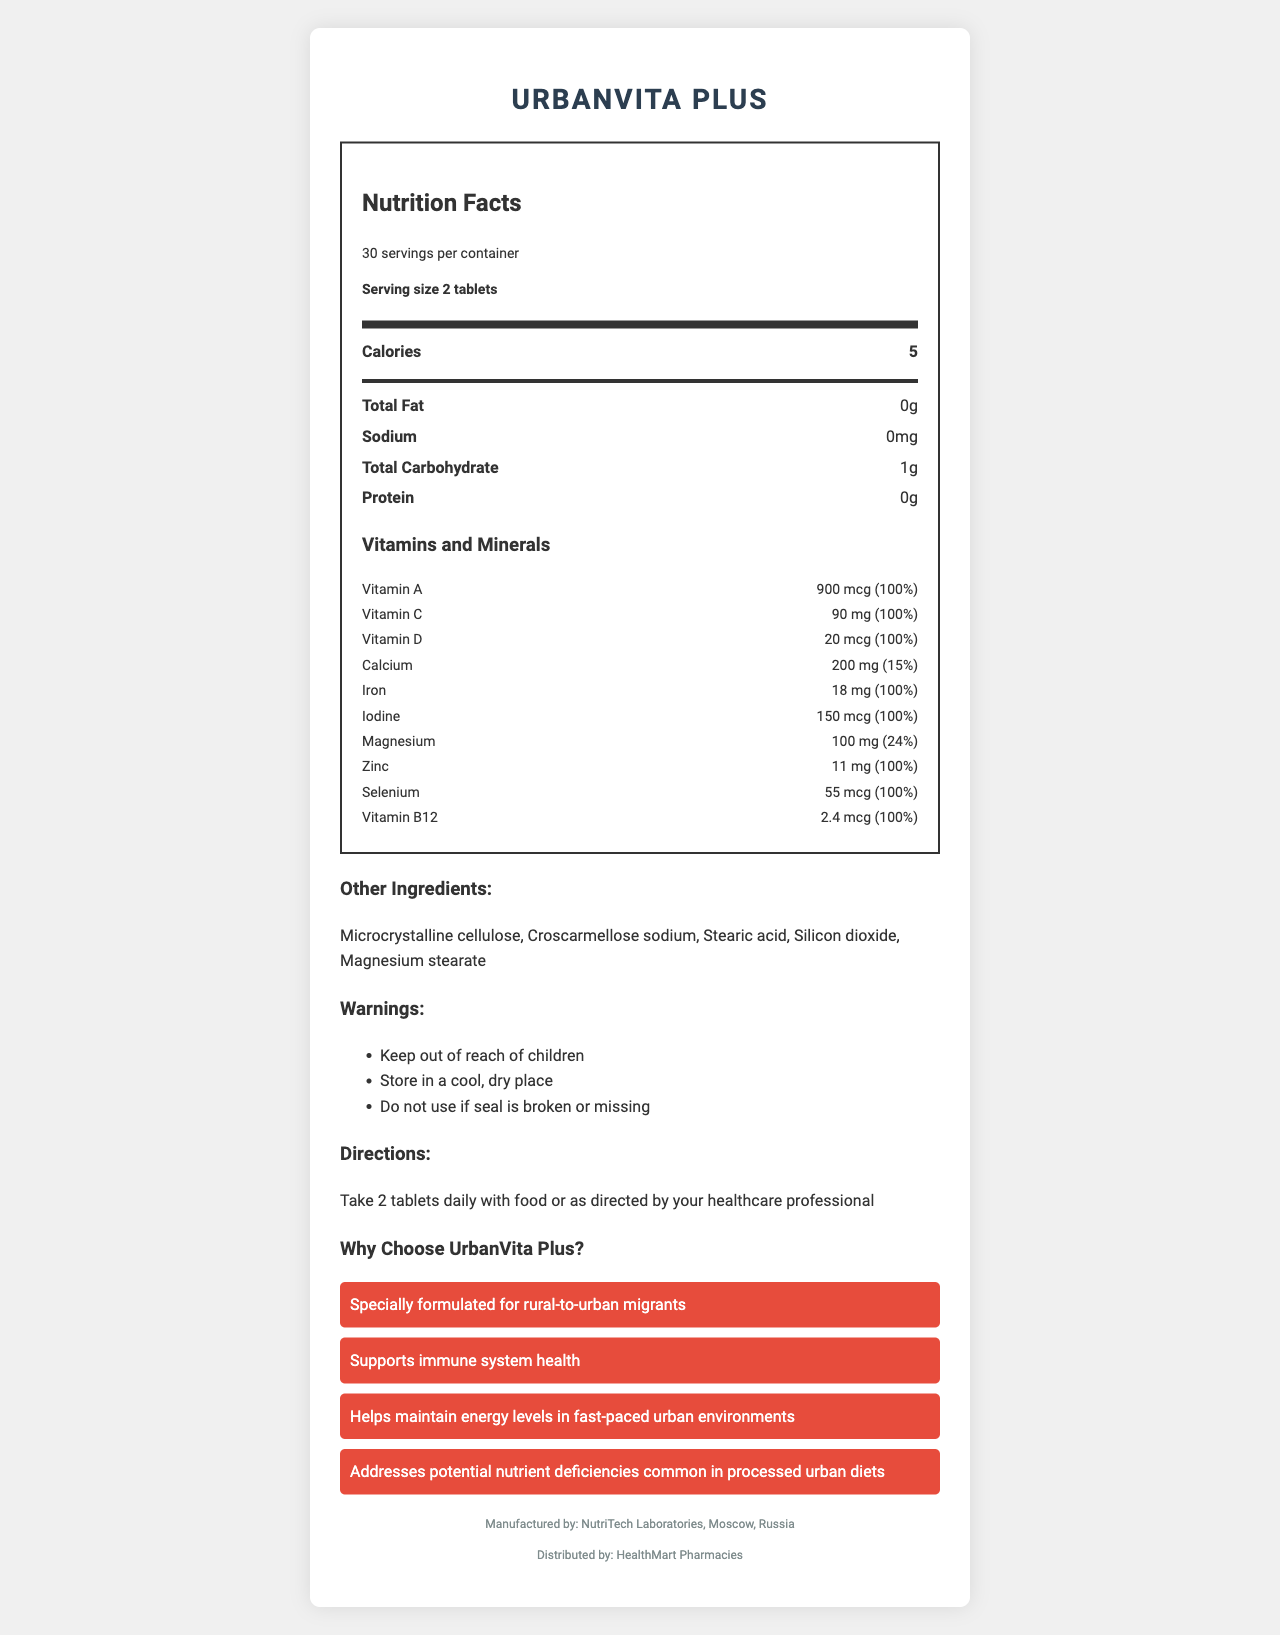which product name is displayed? The document is titled "UrbanVita Plus Nutrition Facts," indicating the product name is UrbanVita Plus.
Answer: UrbanVita Plus what is the serving size? The document states "Serving size: 2 tablets."
Answer: 2 tablets how many servings are there per container? The document indicates there are 30 servings per container.
Answer: 30 how many calories are in a serving? The document lists that each serving contains 5 calories.
Answer: 5 how much Vitamin C is in a serving? Under the vitamins and minerals section, Vitamin C is listed as containing 90 mg per serving with a daily value of 100%.
Answer: 90 mg which vitamin has the highest percentage daily value? A. Vitamin A B. Vitamin D C. Calcium Vitamin A is listed with 100% daily value, while Vitamin D also shows 100%, but Calcium only has 15%.
Answer: A which of the following ingredients is not included in UrbanVita Plus? (1) Microcrystalline cellulose (2) Croscarmellose sodium (3) Lactose (4) Stearic acid Lactose is not listed under the other ingredients, unlike Microcrystalline cellulose, Croscarmellose sodium, and Stearic acid.
Answer: 3 does UrbanVita Plus contain any known allergens? The allergen information states "Contains no known allergens."
Answer: No is UrbanVita Plus manufactured in the USA? The document mentions that UrbanVita Plus is manufactured by NutriTech Laboratories, Moscow, Russia.
Answer: No summarize the main purpose and benefits of UrbanVita Plus. The document markets UrbanVita Plus as specially formulated for rural-to-urban migrants, emphasizing benefits such as supporting immune health, maintaining energy levels in fast-paced urban settings, and addressing nutrient deficiencies.
Answer: UrbanVita Plus is a vitamin supplement designed for rural-to-urban migrants to support immune system health, maintain energy levels in urban environments, and address potential nutrient deficiencies common in processed urban diets. who distributes UrbanVita Plus? The document indicates that UrbanVita Plus is distributed by HealthMart Pharmacies.
Answer: HealthMart Pharmacies how should UrbanVita Plus be stored? One of the warnings states that the product should be stored in a cool, dry place.
Answer: In a cool, dry place list three minerals included in the supplement The document lists Calcium (200 mg, 15%), Iron (18 mg, 100%), and Magnesium (100 mg, 24%) under the vitamins and minerals section.
Answer: Calcium, Iron, Magnesium group the following nutrients by their daily value percentage: 100%, less than 100% The daily values are listed as 100% for Vitamin A, Vitamin C, Vitamin D, Iron, Iodine, Zinc, Selenium, and Vitamin B12; Calcium is 15% and Magnesium is 24%.
Answer: 100%: Vitamin A, Vitamin C, Vitamin D, Iron, Iodine, Zinc, Selenium, Vitamin B12; Less than 100%: Calcium, Magnesium what is the primary marketing claim for UrbanVita Plus? The first marketing claim highlighted states "Specially formulated for rural-to-urban migrants."
Answer: Specially formulated for rural-to-urban migrants which ingredient is used as an anti-caking agent? Silicon dioxide is commonly used as an anti-caking agent and is listed under other ingredients.
Answer: Silicon dioxide can you determine how much the product costs based on the document? The document does not provide any pricing information for UrbanVita Plus.
Answer: Not enough information what is the total amount of Magnesium in one serving? The document lists Magnesium under the vitamins and minerals section as containing 100 mg per serving.
Answer: 100 mg which warning is given about the product's seal? One of the warnings listed is "Do not use if seal is broken or missing."
Answer: Do not use if seal is broken or missing what are the storage conditions recommended for UrbanVita Plus? The document advises storing the product in a cool, dry place under the warnings section.
Answer: Cool, dry place 